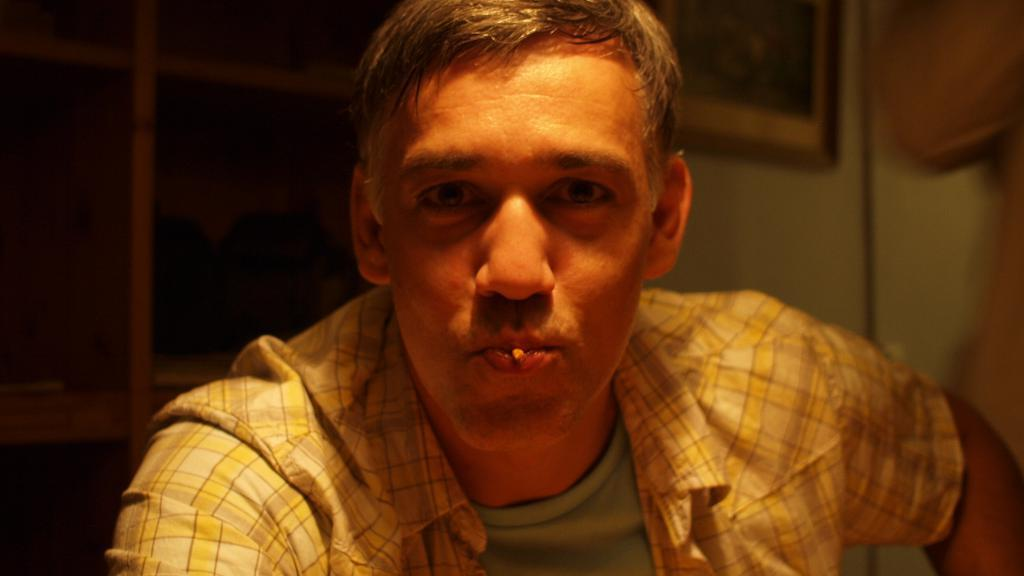Who or what is present in the image? There is a person in the image. What can be seen on the wall in the background of the image? There is a frame on the wall in the background of the image. Can you describe any other objects or features in the background of the image? There are other unspecified objects in the background of the image. What type of tax is being discussed in the image? There is no mention of tax or any discussion in the image; it features a person and a frame on the wall in the background. Can you identify the animal that is present in the image? There is no animal present in the image. 